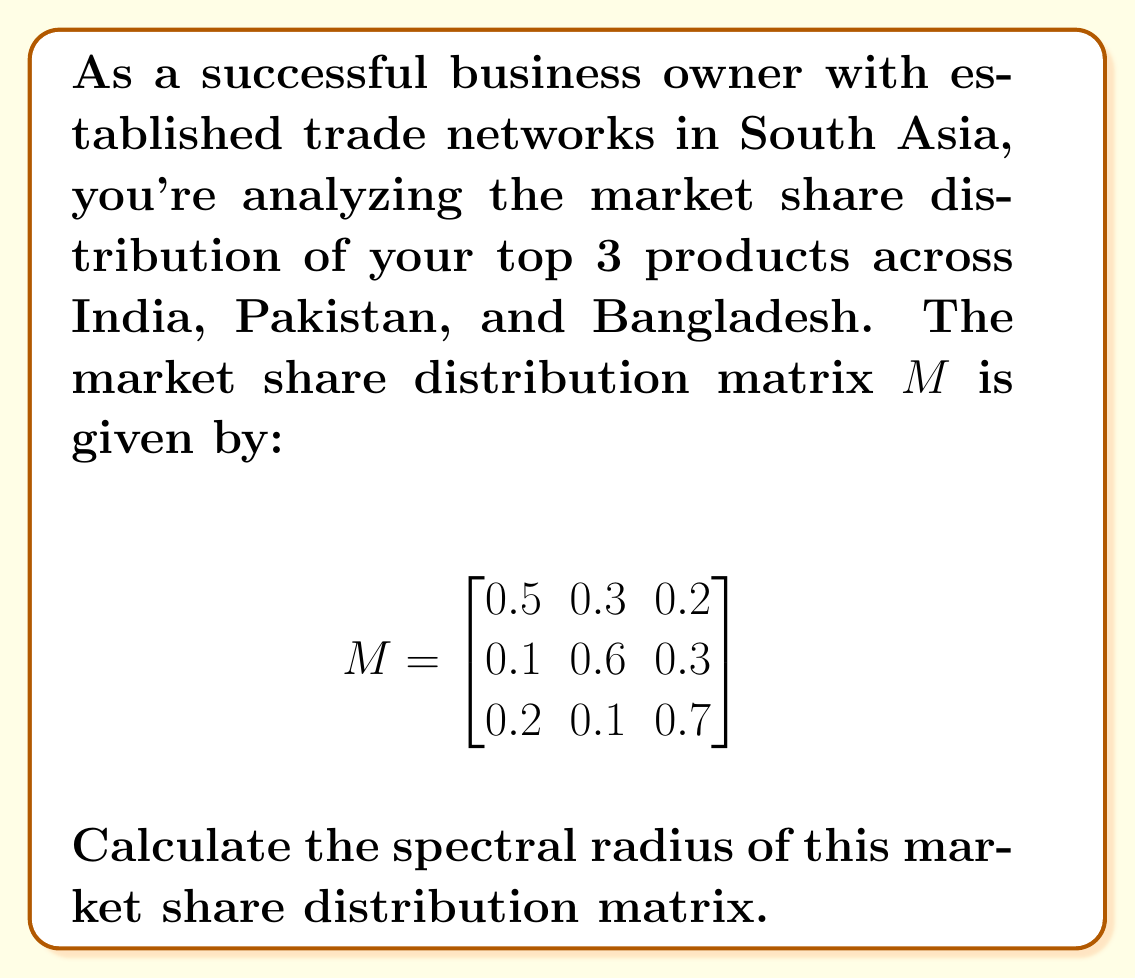Give your solution to this math problem. To calculate the spectral radius of the matrix $M$, we need to follow these steps:

1) First, we need to find the characteristic polynomial of $M$:
   $det(M - \lambda I) = 0$

2) Expand the determinant:
   $$\begin{vmatrix}
   0.5-\lambda & 0.3 & 0.2 \\
   0.1 & 0.6-\lambda & 0.3 \\
   0.2 & 0.1 & 0.7-\lambda
   \end{vmatrix} = 0$$

3) Calculate the determinant:
   $(0.5-\lambda)[(0.6-\lambda)(0.7-\lambda)-0.03] - 0.3[0.1(0.7-\lambda)-0.06] + 0.2[0.1(0.6-\lambda)-0.03] = 0$

4) Simplify:
   $-\lambda^3 + 1.8\lambda^2 - 0.83\lambda + 0.1 = 0$

5) The roots of this polynomial are the eigenvalues of $M$. We can use a numerical method to find these roots:
   $\lambda_1 \approx 1$
   $\lambda_2 \approx 0.5$
   $\lambda_3 \approx 0.3$

6) The spectral radius is the maximum absolute value of the eigenvalues:
   $\rho(M) = \max(|\lambda_1|, |\lambda_2|, |\lambda_3|) = \max(1, 0.5, 0.3) = 1$

Therefore, the spectral radius of the market share distribution matrix is 1.
Answer: 1 